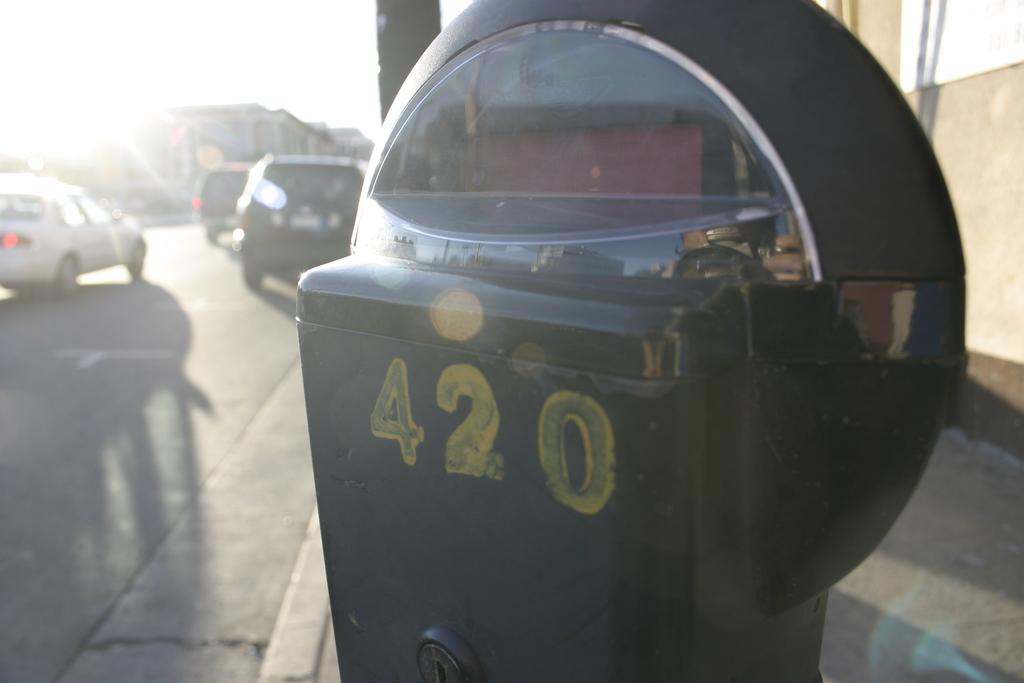What number is displayed over there?
Make the answer very short. 420. 